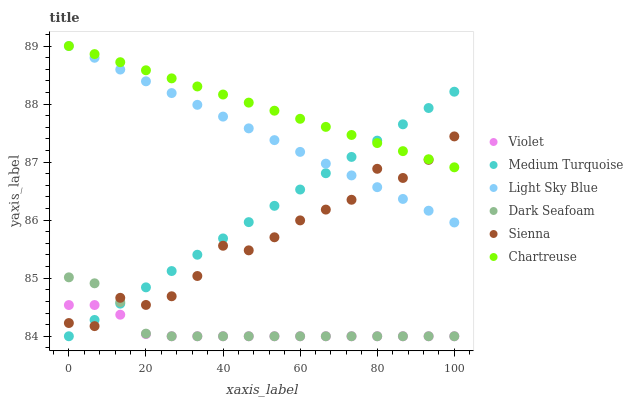Does Violet have the minimum area under the curve?
Answer yes or no. Yes. Does Chartreuse have the maximum area under the curve?
Answer yes or no. Yes. Does Sienna have the minimum area under the curve?
Answer yes or no. No. Does Sienna have the maximum area under the curve?
Answer yes or no. No. Is Chartreuse the smoothest?
Answer yes or no. Yes. Is Sienna the roughest?
Answer yes or no. Yes. Is Dark Seafoam the smoothest?
Answer yes or no. No. Is Dark Seafoam the roughest?
Answer yes or no. No. Does Dark Seafoam have the lowest value?
Answer yes or no. Yes. Does Sienna have the lowest value?
Answer yes or no. No. Does Light Sky Blue have the highest value?
Answer yes or no. Yes. Does Sienna have the highest value?
Answer yes or no. No. Is Violet less than Chartreuse?
Answer yes or no. Yes. Is Light Sky Blue greater than Dark Seafoam?
Answer yes or no. Yes. Does Dark Seafoam intersect Medium Turquoise?
Answer yes or no. Yes. Is Dark Seafoam less than Medium Turquoise?
Answer yes or no. No. Is Dark Seafoam greater than Medium Turquoise?
Answer yes or no. No. Does Violet intersect Chartreuse?
Answer yes or no. No. 